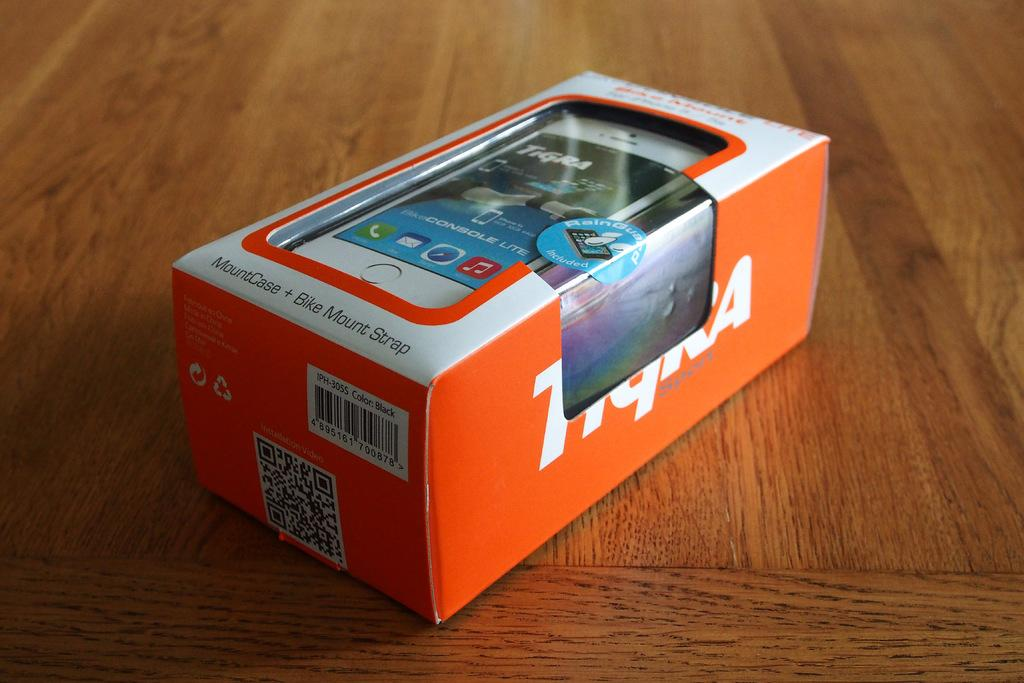<image>
Relay a brief, clear account of the picture shown. A box containing a Tigra Sport MountCase + Bike Mount Strap 